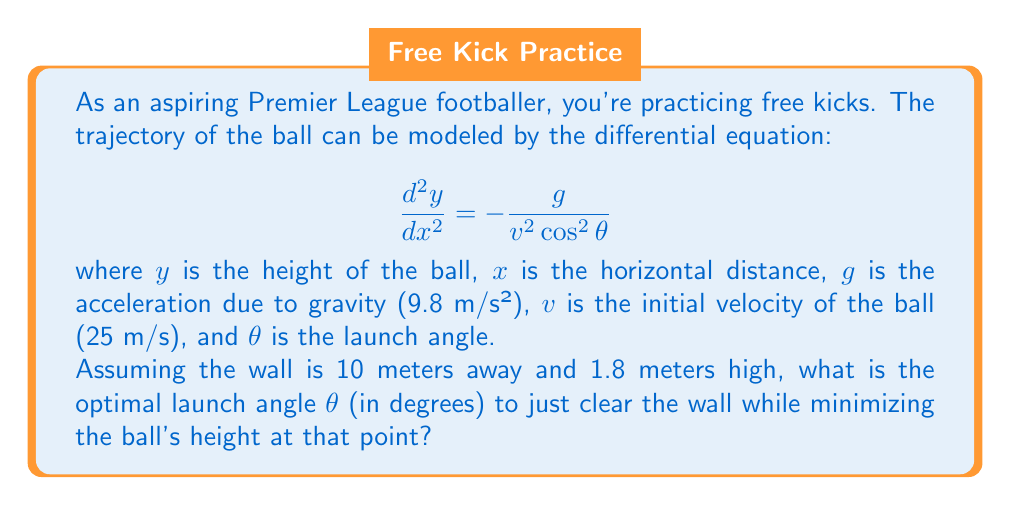Could you help me with this problem? Let's approach this step-by-step:

1) First, we need to solve the differential equation. Integrating once gives us:

   $$ \frac{dy}{dx} = -\frac{gx}{v^2\cos^2\theta} + C_1 $$

2) Integrating again:

   $$ y = -\frac{gx^2}{2v^2\cos^2\theta} + C_1x + C_2 $$

3) Using the initial conditions (at x = 0, y = 0 and dy/dx = tan θ), we can find C₁ and C₂:

   $$ y = x\tan\theta - \frac{gx^2}{2v^2\cos^2\theta} $$

4) This is the equation of the ball's trajectory. At the wall (x = 10), we want y to be just above 1.8:

   $$ 1.8 = 10\tan\theta - \frac{9.8 \cdot 10^2}{2 \cdot 25^2\cos^2\theta} $$

5) Simplifying:

   $$ 1.8 = 10\tan\theta - \frac{19.6}{12.5\cos^2\theta} $$

6) To minimize the height at this point, we want the smallest θ that satisfies this equation. We can solve this numerically using a computer or graphing calculator.

7) The solution is approximately θ = 10.47°.
Answer: The optimal launch angle θ is approximately 10.47°. 